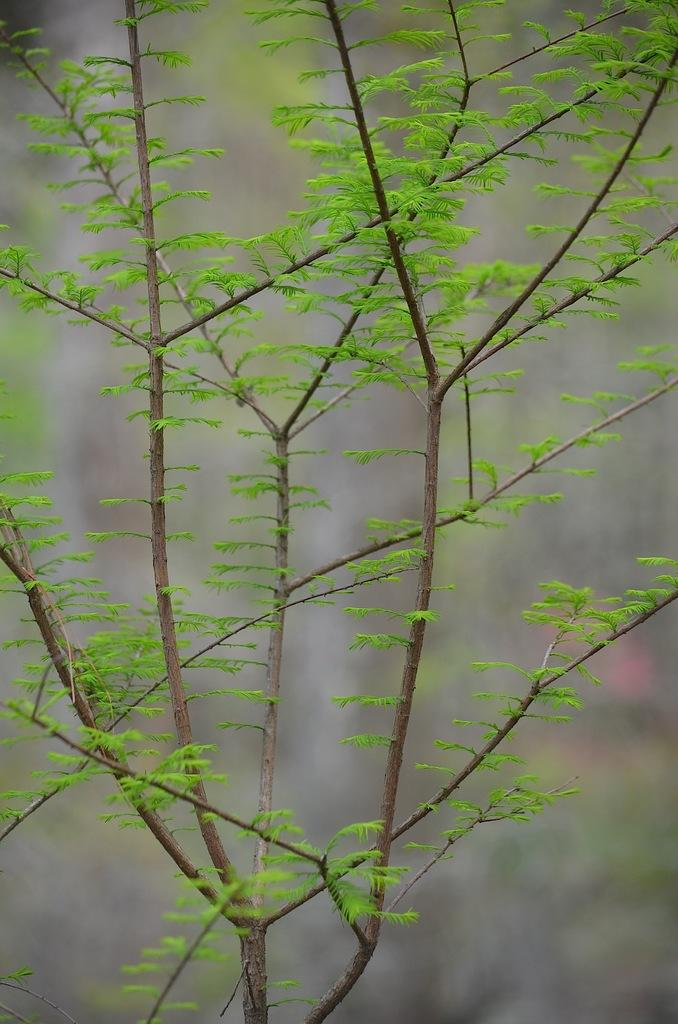What is present in the image? There is a plant in the image. What can be observed about the plant's leaves? The plant has green leaves. How many children are playing with the plant in the image? There are no children present in the image; it only features a plant with green leaves. What time of day is depicted in the image? The provided facts do not mention the time of day, so it cannot be determined from the image. 